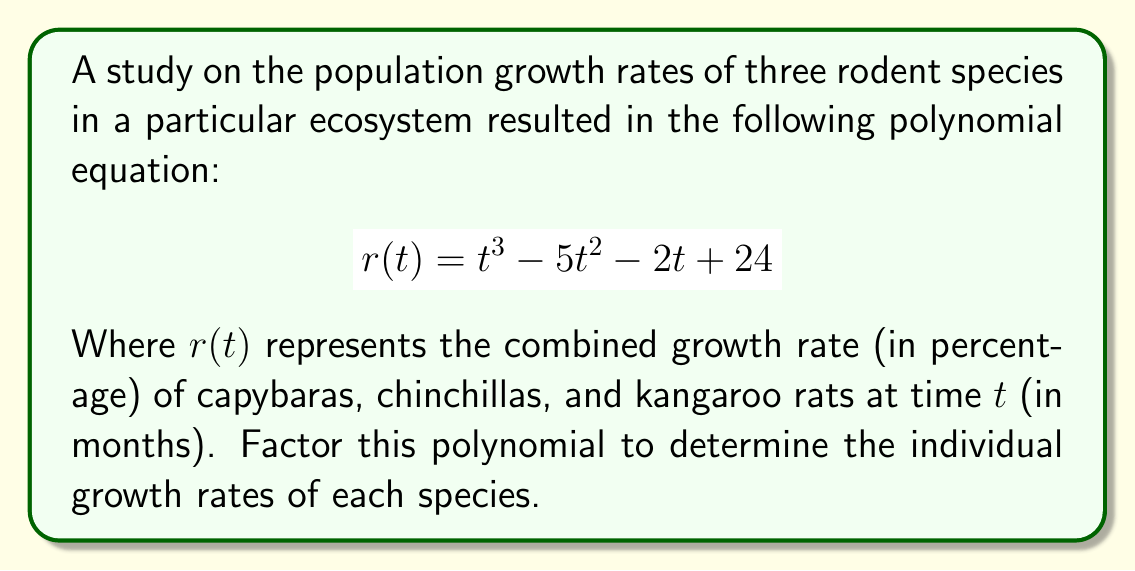Help me with this question. Let's approach this step-by-step:

1) First, we need to identify the factors of the constant term, 24. The factors are: ±1, ±2, ±3, ±4, ±6, ±8, ±12, ±24.

2) We'll use the rational root theorem to find potential roots. The potential rational roots are the factors of 24 divided by the factors of the leading coefficient (which is 1 in this case).

3) Let's test these potential roots using synthetic division or by plugging them into the original equation.

4) After testing, we find that 4 is a root of the polynomial. So $(t-4)$ is a factor.

5) Dividing the original polynomial by $(t-4)$:

   $$ \frac{t^3 - 5t^2 - 2t + 24}{t - 4} = t^2 - t - 6 $$

6) Now we need to factor the quadratic $t^2 - t - 6$. We can do this by finding two numbers that multiply to give -6 and add to give -1.

7) These numbers are -3 and 2. So we can factor $t^2 - t - 6$ as $(t-3)(t+2)$.

8) Therefore, the complete factorization is:

   $$ r(t) = (t-4)(t-3)(t+2) $$

9) This means the individual growth rates are 4%, 3%, and -2% per month for the three species.
Answer: $$ r(t) = (t-4)(t-3)(t+2) $$ 